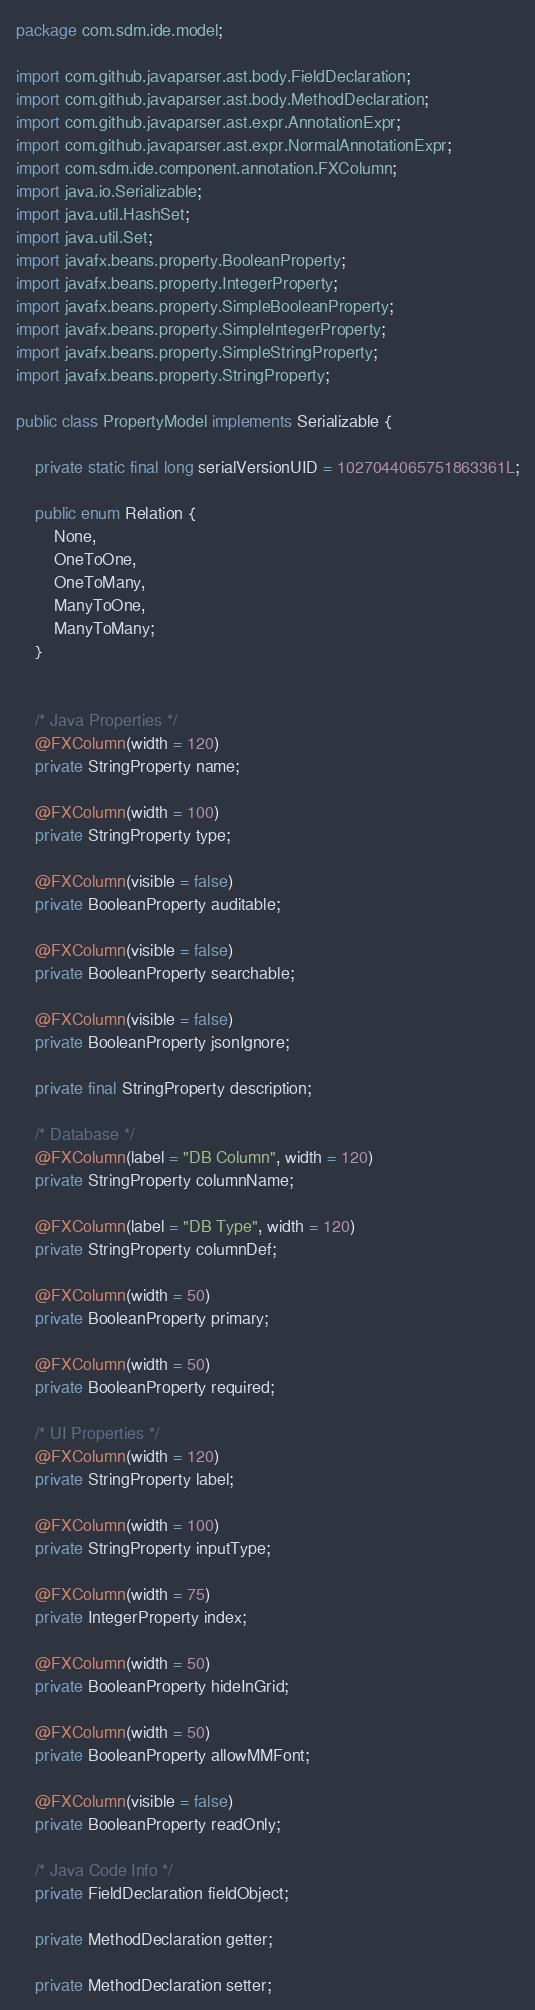<code> <loc_0><loc_0><loc_500><loc_500><_Java_>package com.sdm.ide.model;

import com.github.javaparser.ast.body.FieldDeclaration;
import com.github.javaparser.ast.body.MethodDeclaration;
import com.github.javaparser.ast.expr.AnnotationExpr;
import com.github.javaparser.ast.expr.NormalAnnotationExpr;
import com.sdm.ide.component.annotation.FXColumn;
import java.io.Serializable;
import java.util.HashSet;
import java.util.Set;
import javafx.beans.property.BooleanProperty;
import javafx.beans.property.IntegerProperty;
import javafx.beans.property.SimpleBooleanProperty;
import javafx.beans.property.SimpleIntegerProperty;
import javafx.beans.property.SimpleStringProperty;
import javafx.beans.property.StringProperty;

public class PropertyModel implements Serializable {

    private static final long serialVersionUID = 1027044065751863361L;

    public enum Relation {
        None,
        OneToOne,
        OneToMany,
        ManyToOne,
        ManyToMany;
    }


    /* Java Properties */
    @FXColumn(width = 120)
    private StringProperty name;

    @FXColumn(width = 100)
    private StringProperty type;

    @FXColumn(visible = false)
    private BooleanProperty auditable;

    @FXColumn(visible = false)
    private BooleanProperty searchable;

    @FXColumn(visible = false)
    private BooleanProperty jsonIgnore;

    private final StringProperty description;

    /* Database */
    @FXColumn(label = "DB Column", width = 120)
    private StringProperty columnName;

    @FXColumn(label = "DB Type", width = 120)
    private StringProperty columnDef;

    @FXColumn(width = 50)
    private BooleanProperty primary;

    @FXColumn(width = 50)
    private BooleanProperty required;

    /* UI Properties */
    @FXColumn(width = 120)
    private StringProperty label;

    @FXColumn(width = 100)
    private StringProperty inputType;

    @FXColumn(width = 75)
    private IntegerProperty index;

    @FXColumn(width = 50)
    private BooleanProperty hideInGrid;

    @FXColumn(width = 50)
    private BooleanProperty allowMMFont;

    @FXColumn(visible = false)
    private BooleanProperty readOnly;

    /* Java Code Info */
    private FieldDeclaration fieldObject;

    private MethodDeclaration getter;

    private MethodDeclaration setter;
</code> 